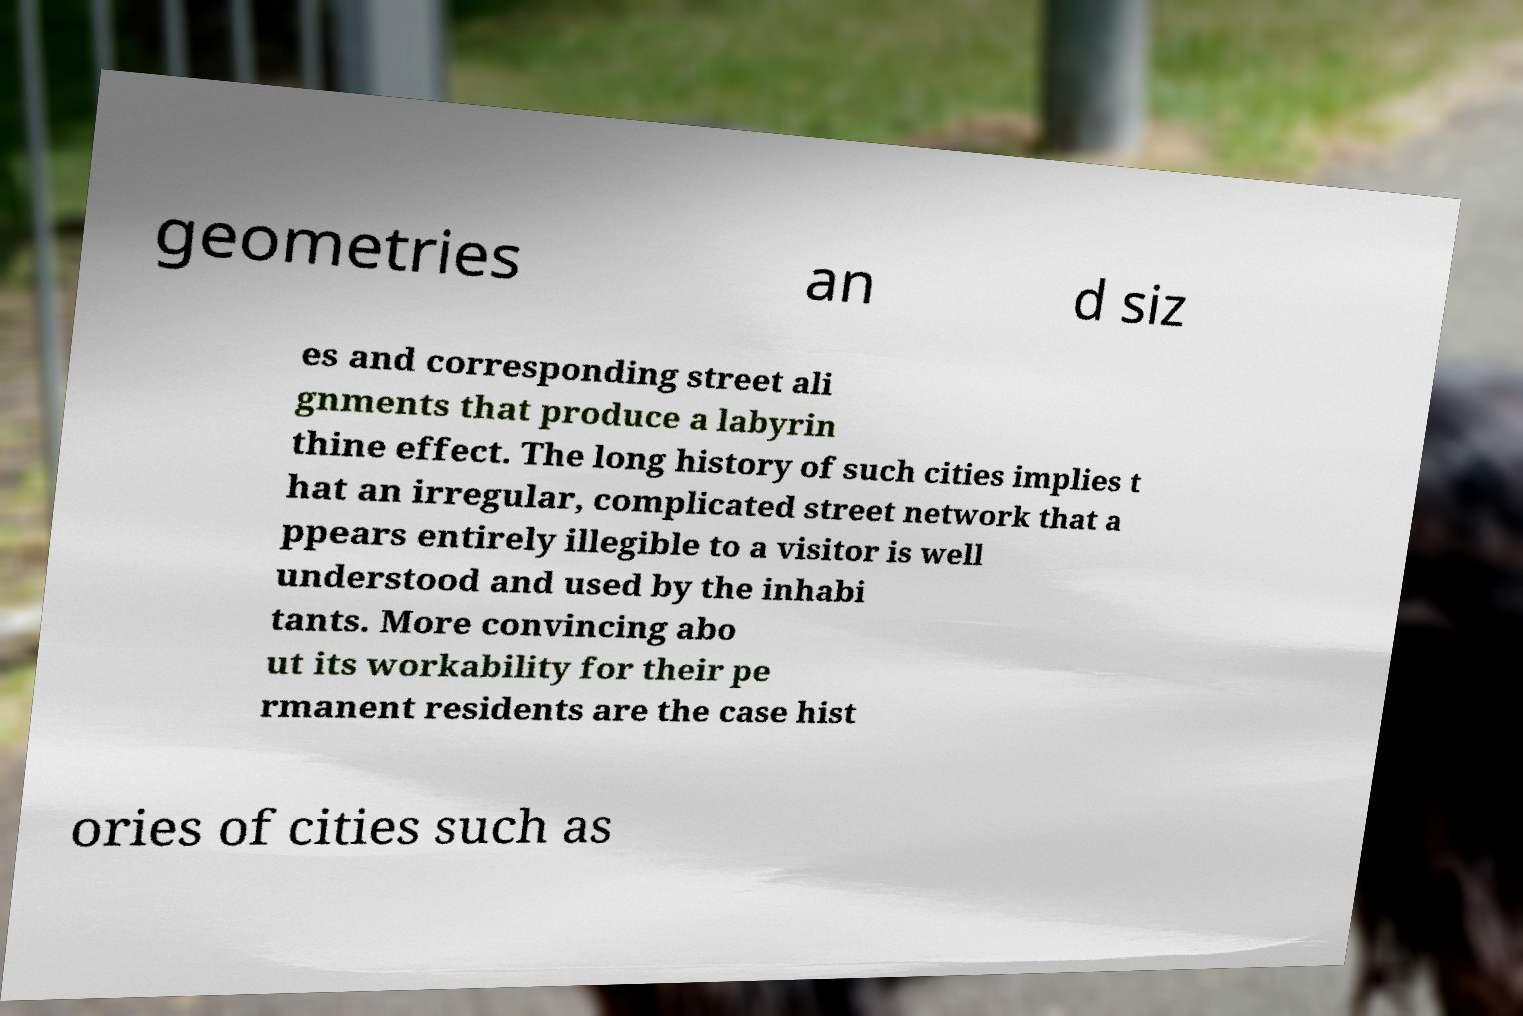Could you extract and type out the text from this image? geometries an d siz es and corresponding street ali gnments that produce a labyrin thine effect. The long history of such cities implies t hat an irregular, complicated street network that a ppears entirely illegible to a visitor is well understood and used by the inhabi tants. More convincing abo ut its workability for their pe rmanent residents are the case hist ories of cities such as 